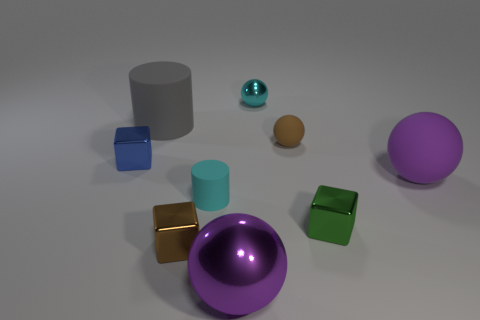Subtract all red cylinders. How many purple balls are left? 2 Subtract 1 cubes. How many cubes are left? 2 Subtract all small blue metallic blocks. How many blocks are left? 2 Subtract all cyan spheres. How many spheres are left? 3 Add 1 big gray things. How many objects exist? 10 Subtract all blue spheres. Subtract all green cylinders. How many spheres are left? 4 Subtract all blocks. How many objects are left? 6 Subtract all small blue shiny objects. Subtract all large purple metal balls. How many objects are left? 7 Add 6 green objects. How many green objects are left? 7 Add 5 small rubber cylinders. How many small rubber cylinders exist? 6 